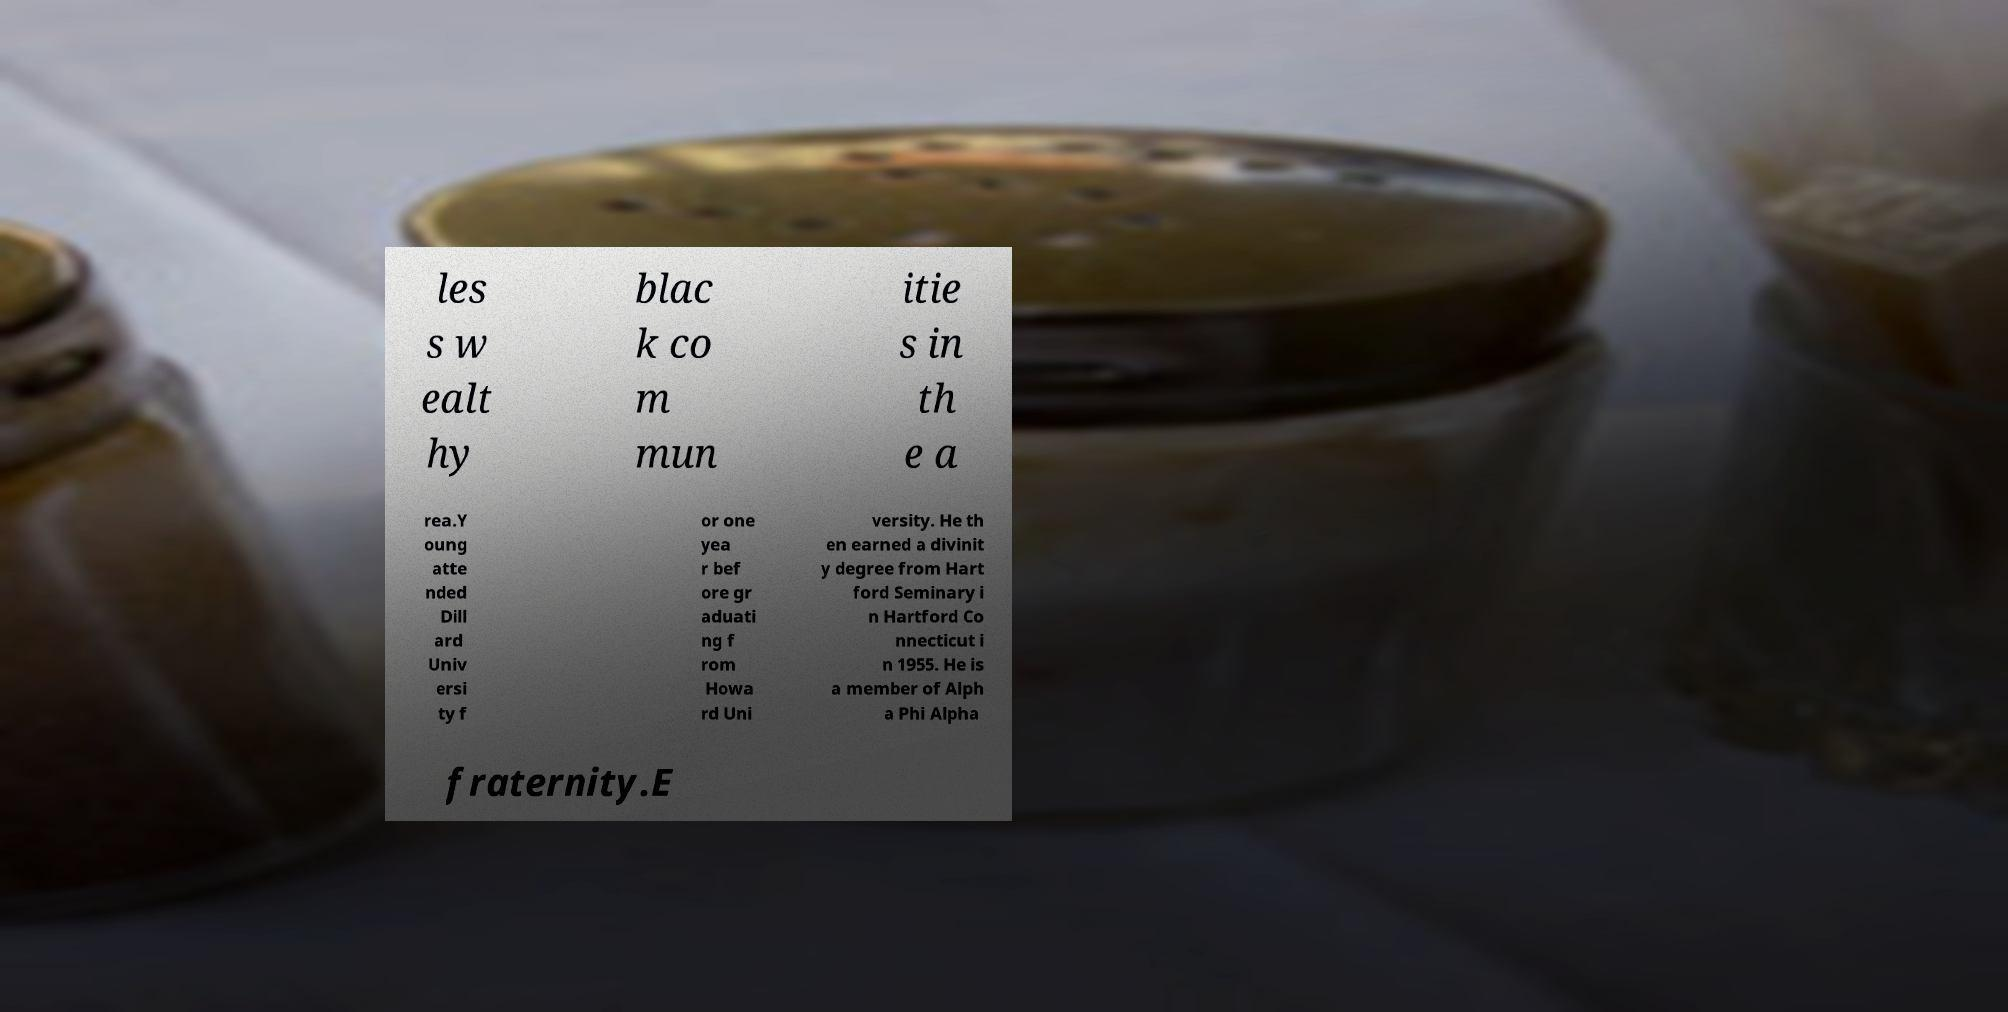Please read and relay the text visible in this image. What does it say? les s w ealt hy blac k co m mun itie s in th e a rea.Y oung atte nded Dill ard Univ ersi ty f or one yea r bef ore gr aduati ng f rom Howa rd Uni versity. He th en earned a divinit y degree from Hart ford Seminary i n Hartford Co nnecticut i n 1955. He is a member of Alph a Phi Alpha fraternity.E 